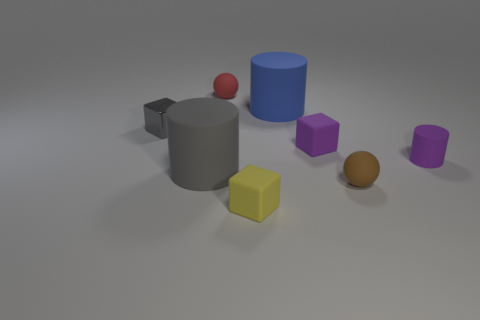Add 2 small metallic cubes. How many objects exist? 10 Subtract all cylinders. How many objects are left? 5 Add 4 spheres. How many spheres exist? 6 Subtract 1 purple blocks. How many objects are left? 7 Subtract all purple things. Subtract all small gray things. How many objects are left? 5 Add 6 big matte cylinders. How many big matte cylinders are left? 8 